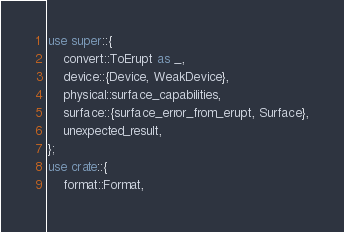<code> <loc_0><loc_0><loc_500><loc_500><_Rust_>use super::{
    convert::ToErupt as _,
    device::{Device, WeakDevice},
    physical::surface_capabilities,
    surface::{surface_error_from_erupt, Surface},
    unexpected_result,
};
use crate::{
    format::Format,</code> 